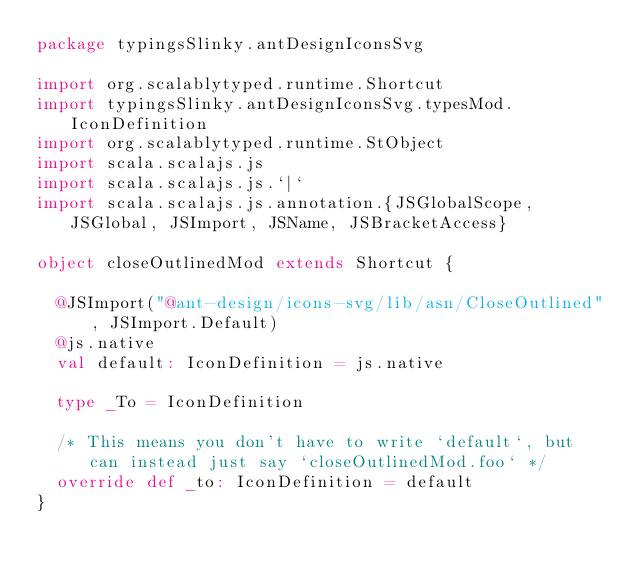Convert code to text. <code><loc_0><loc_0><loc_500><loc_500><_Scala_>package typingsSlinky.antDesignIconsSvg

import org.scalablytyped.runtime.Shortcut
import typingsSlinky.antDesignIconsSvg.typesMod.IconDefinition
import org.scalablytyped.runtime.StObject
import scala.scalajs.js
import scala.scalajs.js.`|`
import scala.scalajs.js.annotation.{JSGlobalScope, JSGlobal, JSImport, JSName, JSBracketAccess}

object closeOutlinedMod extends Shortcut {
  
  @JSImport("@ant-design/icons-svg/lib/asn/CloseOutlined", JSImport.Default)
  @js.native
  val default: IconDefinition = js.native
  
  type _To = IconDefinition
  
  /* This means you don't have to write `default`, but can instead just say `closeOutlinedMod.foo` */
  override def _to: IconDefinition = default
}
</code> 